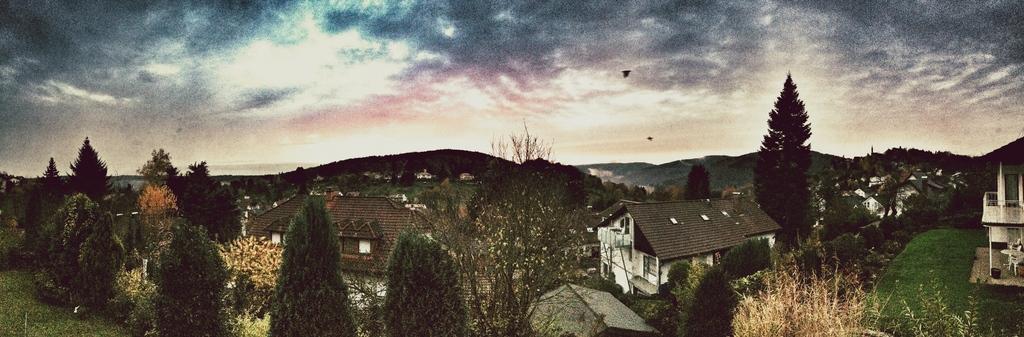How would you summarize this image in a sentence or two? In this image I can see few houses, windows, trees, table, chairs and the sky. 